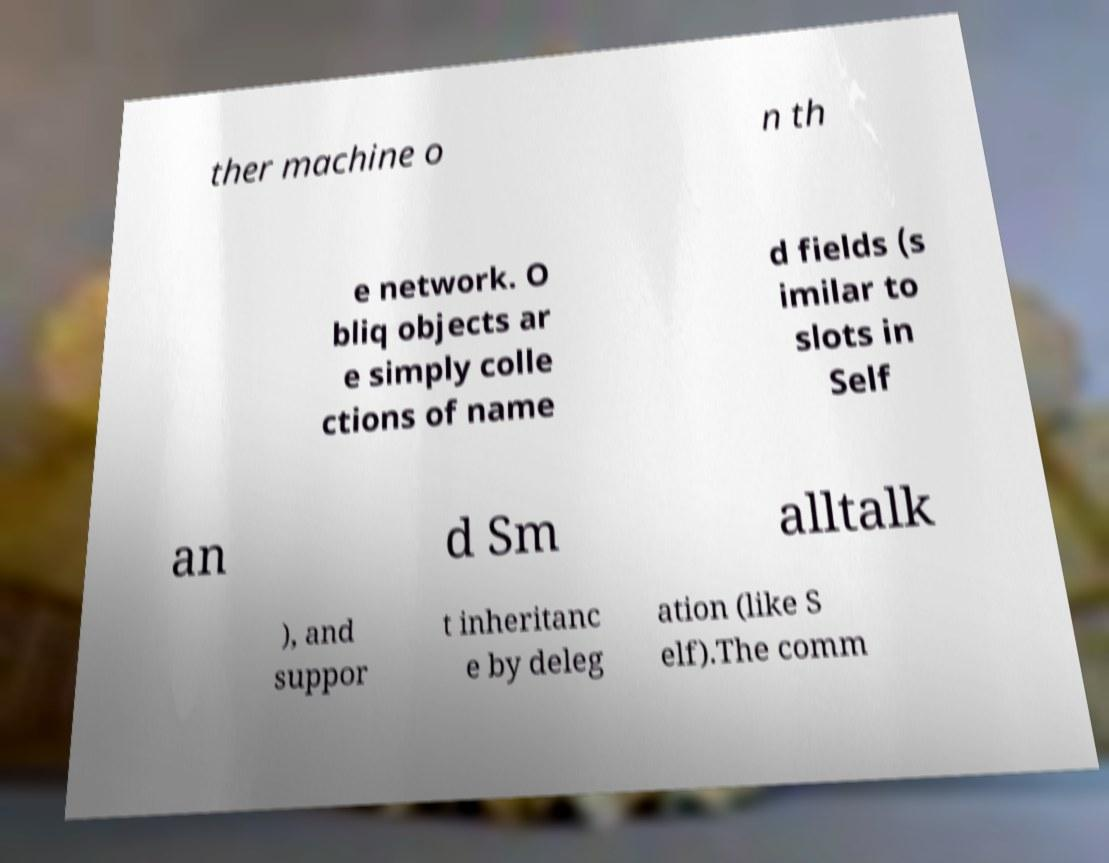What messages or text are displayed in this image? I need them in a readable, typed format. ther machine o n th e network. O bliq objects ar e simply colle ctions of name d fields (s imilar to slots in Self an d Sm alltalk ), and suppor t inheritanc e by deleg ation (like S elf).The comm 